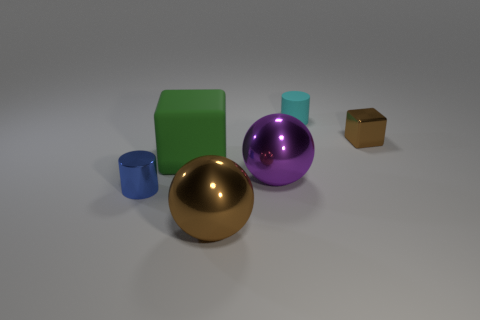Add 3 matte balls. How many objects exist? 9 Subtract all blocks. How many objects are left? 4 Subtract 1 brown cubes. How many objects are left? 5 Subtract all blue metal cylinders. Subtract all small objects. How many objects are left? 2 Add 4 big green blocks. How many big green blocks are left? 5 Add 2 small metal cylinders. How many small metal cylinders exist? 3 